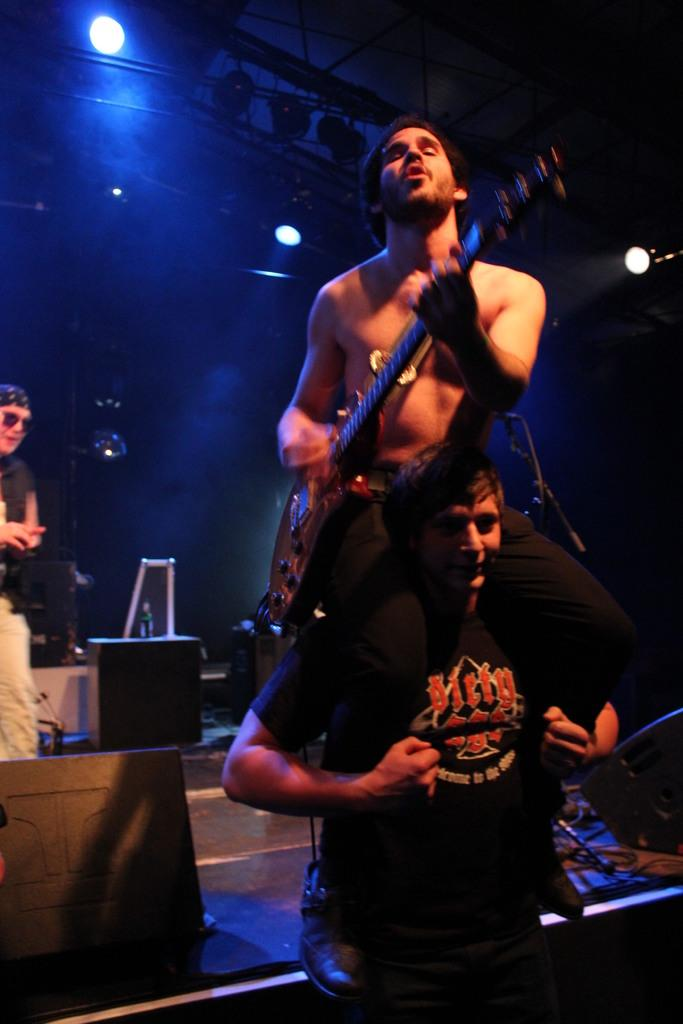What is the person on the shoulders doing in the image? The person on the shoulders is playing a guitar. What can be seen in the image that might be used for illumination? There are focusing lights in the image. What is placed on the sound box of the guitar? There is a bottle on the sound box of the guitar. Can you describe the person on the left side of the image? There is a person on the left side of the image, but no specific details about them are provided. What type of street trade is happening in the image? There is no indication of any street trade in the image; it features a person playing a guitar while sitting on another person's shoulders. How many dogs are visible in the image? There are no dogs present in the image. 